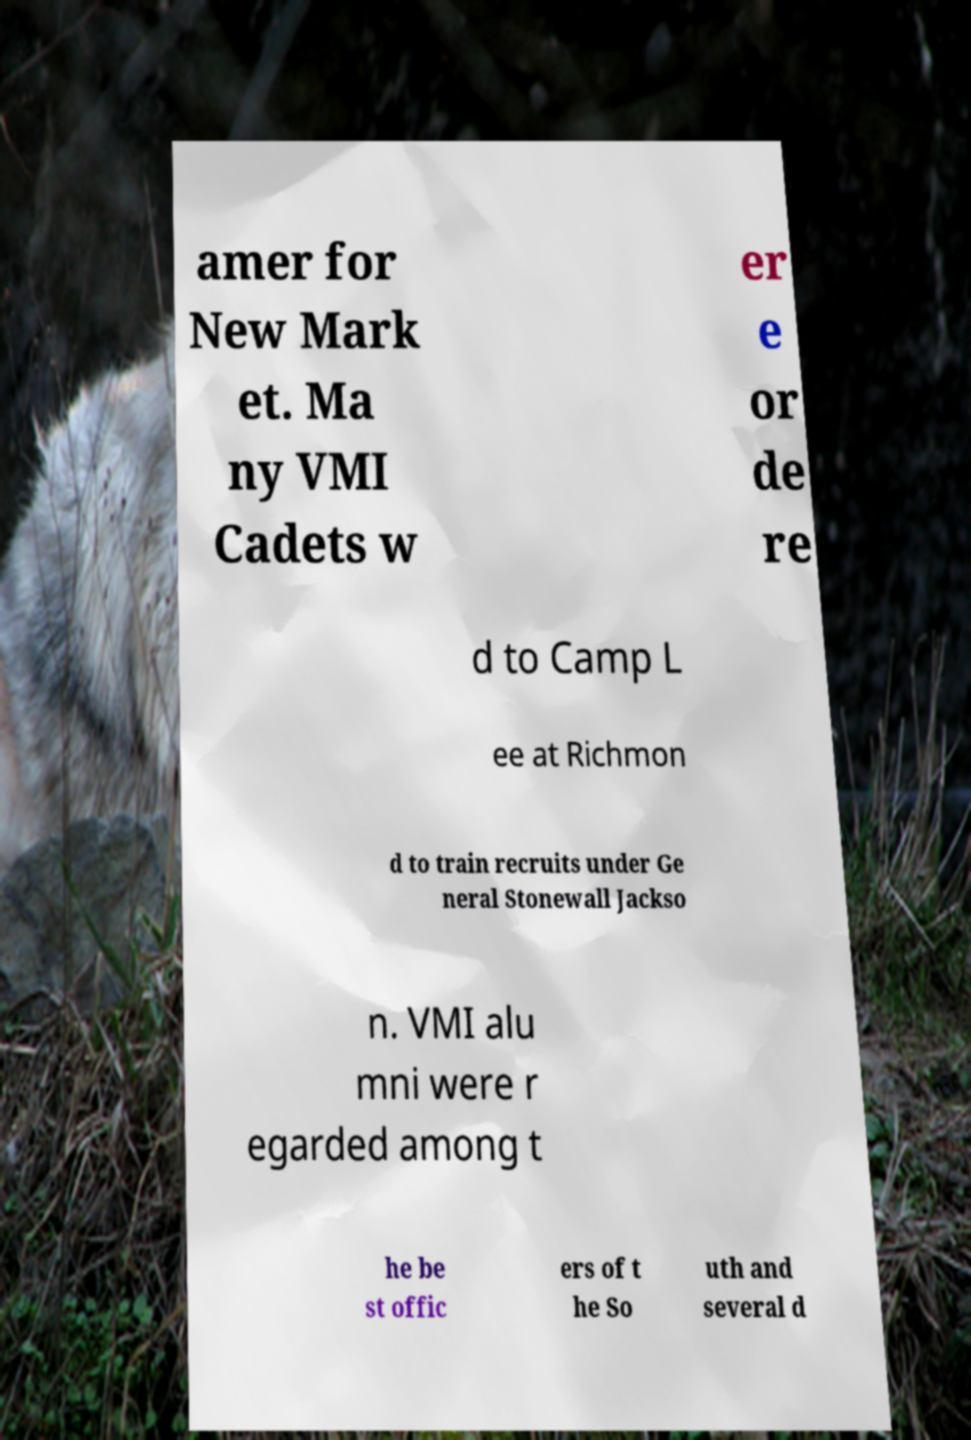Can you accurately transcribe the text from the provided image for me? amer for New Mark et. Ma ny VMI Cadets w er e or de re d to Camp L ee at Richmon d to train recruits under Ge neral Stonewall Jackso n. VMI alu mni were r egarded among t he be st offic ers of t he So uth and several d 